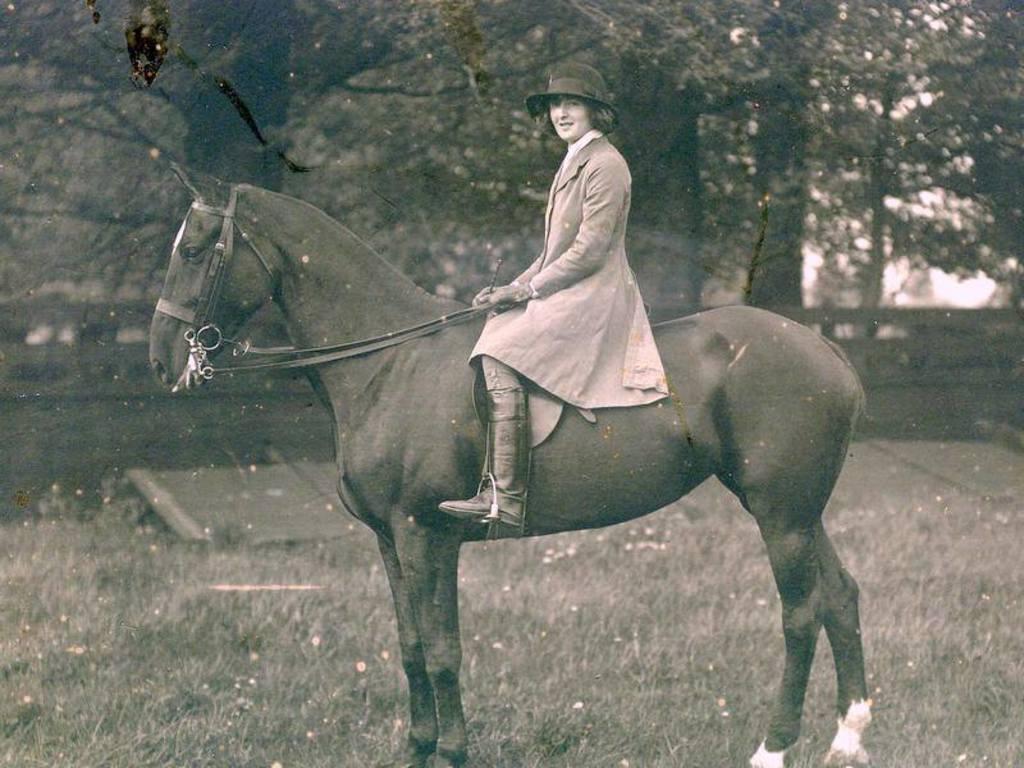How would you summarize this image in a sentence or two? In this image, we can see a person is sitting on the horse and holding ropes. She wore a hat and smiling. At the bottom, we can see grass. Background there are so many trees and few objects. 